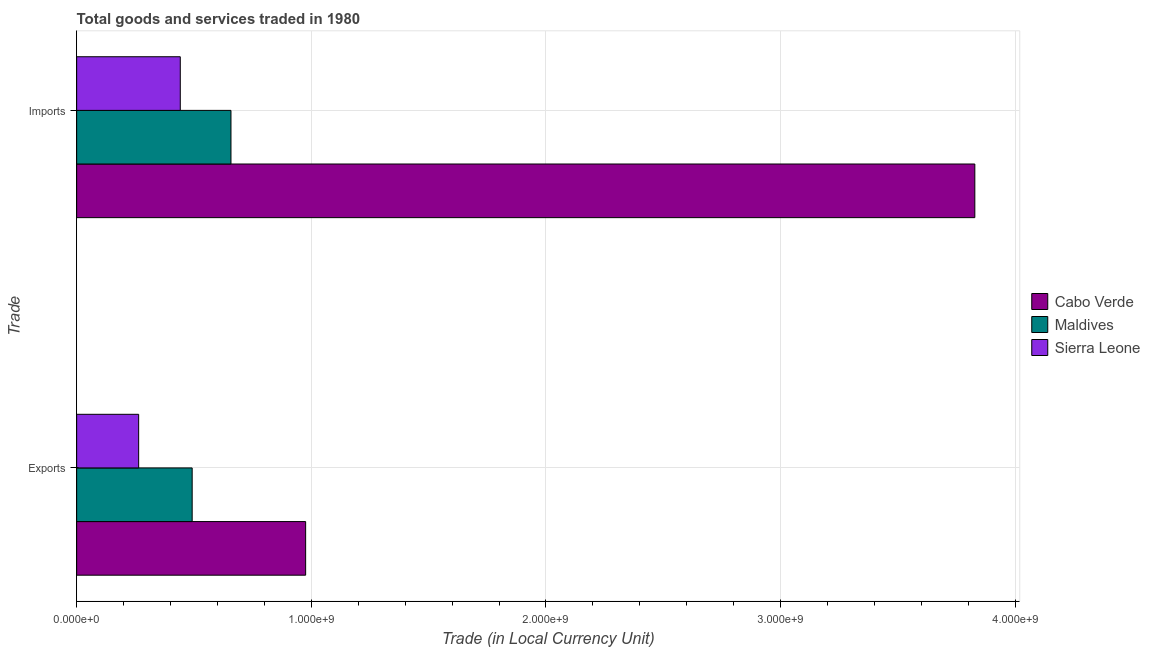How many groups of bars are there?
Provide a succinct answer. 2. Are the number of bars per tick equal to the number of legend labels?
Provide a succinct answer. Yes. How many bars are there on the 1st tick from the top?
Your answer should be very brief. 3. What is the label of the 1st group of bars from the top?
Ensure brevity in your answer.  Imports. What is the export of goods and services in Sierra Leone?
Your response must be concise. 2.64e+08. Across all countries, what is the maximum imports of goods and services?
Keep it short and to the point. 3.83e+09. Across all countries, what is the minimum export of goods and services?
Keep it short and to the point. 2.64e+08. In which country was the export of goods and services maximum?
Keep it short and to the point. Cabo Verde. In which country was the imports of goods and services minimum?
Keep it short and to the point. Sierra Leone. What is the total export of goods and services in the graph?
Offer a very short reply. 1.73e+09. What is the difference between the imports of goods and services in Cabo Verde and that in Maldives?
Keep it short and to the point. 3.17e+09. What is the difference between the imports of goods and services in Maldives and the export of goods and services in Cabo Verde?
Your answer should be compact. -3.18e+08. What is the average imports of goods and services per country?
Provide a succinct answer. 1.64e+09. What is the difference between the imports of goods and services and export of goods and services in Cabo Verde?
Your response must be concise. 2.85e+09. In how many countries, is the export of goods and services greater than 1800000000 LCU?
Provide a short and direct response. 0. What is the ratio of the export of goods and services in Maldives to that in Cabo Verde?
Your response must be concise. 0.5. Is the imports of goods and services in Maldives less than that in Sierra Leone?
Provide a succinct answer. No. In how many countries, is the export of goods and services greater than the average export of goods and services taken over all countries?
Your answer should be very brief. 1. What does the 1st bar from the top in Imports represents?
Offer a terse response. Sierra Leone. What does the 2nd bar from the bottom in Imports represents?
Your answer should be very brief. Maldives. How many bars are there?
Provide a short and direct response. 6. How many countries are there in the graph?
Ensure brevity in your answer.  3. What is the difference between two consecutive major ticks on the X-axis?
Your response must be concise. 1.00e+09. Are the values on the major ticks of X-axis written in scientific E-notation?
Make the answer very short. Yes. Does the graph contain any zero values?
Your answer should be compact. No. Does the graph contain grids?
Your answer should be very brief. Yes. Where does the legend appear in the graph?
Your response must be concise. Center right. How many legend labels are there?
Give a very brief answer. 3. How are the legend labels stacked?
Provide a short and direct response. Vertical. What is the title of the graph?
Offer a very short reply. Total goods and services traded in 1980. Does "Indonesia" appear as one of the legend labels in the graph?
Your answer should be compact. No. What is the label or title of the X-axis?
Make the answer very short. Trade (in Local Currency Unit). What is the label or title of the Y-axis?
Provide a succinct answer. Trade. What is the Trade (in Local Currency Unit) of Cabo Verde in Exports?
Ensure brevity in your answer.  9.76e+08. What is the Trade (in Local Currency Unit) of Maldives in Exports?
Provide a short and direct response. 4.92e+08. What is the Trade (in Local Currency Unit) in Sierra Leone in Exports?
Provide a short and direct response. 2.64e+08. What is the Trade (in Local Currency Unit) in Cabo Verde in Imports?
Provide a short and direct response. 3.83e+09. What is the Trade (in Local Currency Unit) in Maldives in Imports?
Provide a succinct answer. 6.58e+08. What is the Trade (in Local Currency Unit) in Sierra Leone in Imports?
Make the answer very short. 4.42e+08. Across all Trade, what is the maximum Trade (in Local Currency Unit) in Cabo Verde?
Keep it short and to the point. 3.83e+09. Across all Trade, what is the maximum Trade (in Local Currency Unit) of Maldives?
Make the answer very short. 6.58e+08. Across all Trade, what is the maximum Trade (in Local Currency Unit) of Sierra Leone?
Give a very brief answer. 4.42e+08. Across all Trade, what is the minimum Trade (in Local Currency Unit) of Cabo Verde?
Offer a terse response. 9.76e+08. Across all Trade, what is the minimum Trade (in Local Currency Unit) in Maldives?
Offer a very short reply. 4.92e+08. Across all Trade, what is the minimum Trade (in Local Currency Unit) of Sierra Leone?
Offer a very short reply. 2.64e+08. What is the total Trade (in Local Currency Unit) of Cabo Verde in the graph?
Provide a succinct answer. 4.80e+09. What is the total Trade (in Local Currency Unit) in Maldives in the graph?
Make the answer very short. 1.15e+09. What is the total Trade (in Local Currency Unit) of Sierra Leone in the graph?
Keep it short and to the point. 7.06e+08. What is the difference between the Trade (in Local Currency Unit) of Cabo Verde in Exports and that in Imports?
Give a very brief answer. -2.85e+09. What is the difference between the Trade (in Local Currency Unit) in Maldives in Exports and that in Imports?
Provide a succinct answer. -1.65e+08. What is the difference between the Trade (in Local Currency Unit) of Sierra Leone in Exports and that in Imports?
Your answer should be compact. -1.77e+08. What is the difference between the Trade (in Local Currency Unit) in Cabo Verde in Exports and the Trade (in Local Currency Unit) in Maldives in Imports?
Keep it short and to the point. 3.18e+08. What is the difference between the Trade (in Local Currency Unit) in Cabo Verde in Exports and the Trade (in Local Currency Unit) in Sierra Leone in Imports?
Your answer should be very brief. 5.34e+08. What is the difference between the Trade (in Local Currency Unit) of Maldives in Exports and the Trade (in Local Currency Unit) of Sierra Leone in Imports?
Your answer should be very brief. 5.07e+07. What is the average Trade (in Local Currency Unit) in Cabo Verde per Trade?
Offer a terse response. 2.40e+09. What is the average Trade (in Local Currency Unit) of Maldives per Trade?
Offer a very short reply. 5.75e+08. What is the average Trade (in Local Currency Unit) in Sierra Leone per Trade?
Your answer should be very brief. 3.53e+08. What is the difference between the Trade (in Local Currency Unit) in Cabo Verde and Trade (in Local Currency Unit) in Maldives in Exports?
Give a very brief answer. 4.84e+08. What is the difference between the Trade (in Local Currency Unit) in Cabo Verde and Trade (in Local Currency Unit) in Sierra Leone in Exports?
Offer a very short reply. 7.12e+08. What is the difference between the Trade (in Local Currency Unit) in Maldives and Trade (in Local Currency Unit) in Sierra Leone in Exports?
Make the answer very short. 2.28e+08. What is the difference between the Trade (in Local Currency Unit) of Cabo Verde and Trade (in Local Currency Unit) of Maldives in Imports?
Your answer should be very brief. 3.17e+09. What is the difference between the Trade (in Local Currency Unit) of Cabo Verde and Trade (in Local Currency Unit) of Sierra Leone in Imports?
Provide a succinct answer. 3.39e+09. What is the difference between the Trade (in Local Currency Unit) in Maldives and Trade (in Local Currency Unit) in Sierra Leone in Imports?
Offer a terse response. 2.16e+08. What is the ratio of the Trade (in Local Currency Unit) in Cabo Verde in Exports to that in Imports?
Make the answer very short. 0.25. What is the ratio of the Trade (in Local Currency Unit) in Maldives in Exports to that in Imports?
Your response must be concise. 0.75. What is the ratio of the Trade (in Local Currency Unit) in Sierra Leone in Exports to that in Imports?
Your answer should be compact. 0.6. What is the difference between the highest and the second highest Trade (in Local Currency Unit) in Cabo Verde?
Provide a succinct answer. 2.85e+09. What is the difference between the highest and the second highest Trade (in Local Currency Unit) in Maldives?
Your answer should be compact. 1.65e+08. What is the difference between the highest and the second highest Trade (in Local Currency Unit) in Sierra Leone?
Keep it short and to the point. 1.77e+08. What is the difference between the highest and the lowest Trade (in Local Currency Unit) in Cabo Verde?
Make the answer very short. 2.85e+09. What is the difference between the highest and the lowest Trade (in Local Currency Unit) of Maldives?
Make the answer very short. 1.65e+08. What is the difference between the highest and the lowest Trade (in Local Currency Unit) in Sierra Leone?
Provide a succinct answer. 1.77e+08. 